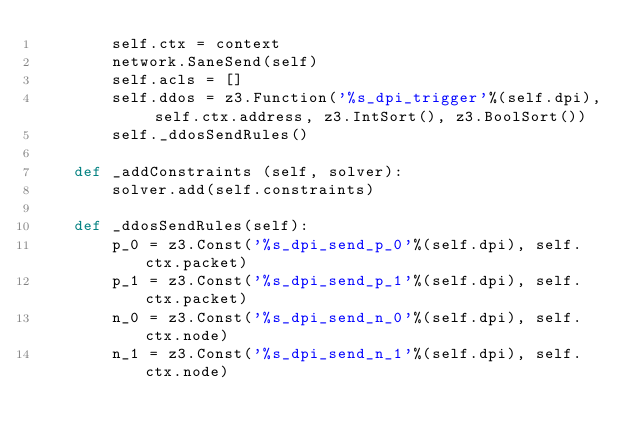<code> <loc_0><loc_0><loc_500><loc_500><_Python_>        self.ctx = context
        network.SaneSend(self)
        self.acls = []
        self.ddos = z3.Function('%s_dpi_trigger'%(self.dpi), self.ctx.address, z3.IntSort(), z3.BoolSort())
        self._ddosSendRules()

    def _addConstraints (self, solver):
        solver.add(self.constraints)

    def _ddosSendRules(self):
        p_0 = z3.Const('%s_dpi_send_p_0'%(self.dpi), self.ctx.packet)
        p_1 = z3.Const('%s_dpi_send_p_1'%(self.dpi), self.ctx.packet)
        n_0 = z3.Const('%s_dpi_send_n_0'%(self.dpi), self.ctx.node)
        n_1 = z3.Const('%s_dpi_send_n_1'%(self.dpi), self.ctx.node)</code> 